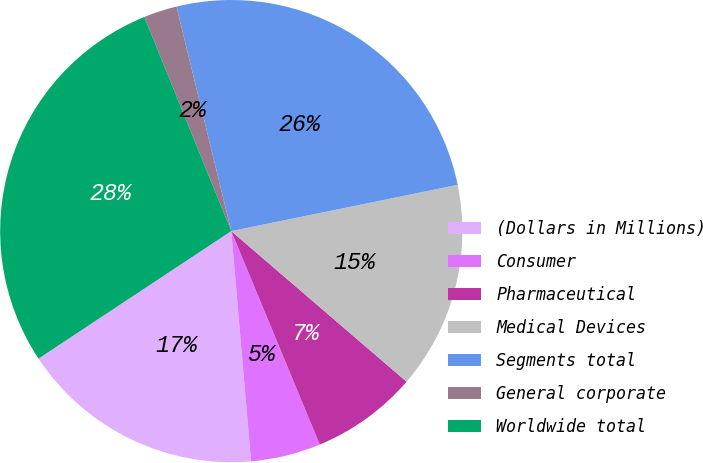<chart> <loc_0><loc_0><loc_500><loc_500><pie_chart><fcel>(Dollars in Millions)<fcel>Consumer<fcel>Pharmaceutical<fcel>Medical Devices<fcel>Segments total<fcel>General corporate<fcel>Worldwide total<nl><fcel>17.06%<fcel>4.89%<fcel>7.45%<fcel>14.5%<fcel>25.6%<fcel>2.33%<fcel>28.16%<nl></chart> 